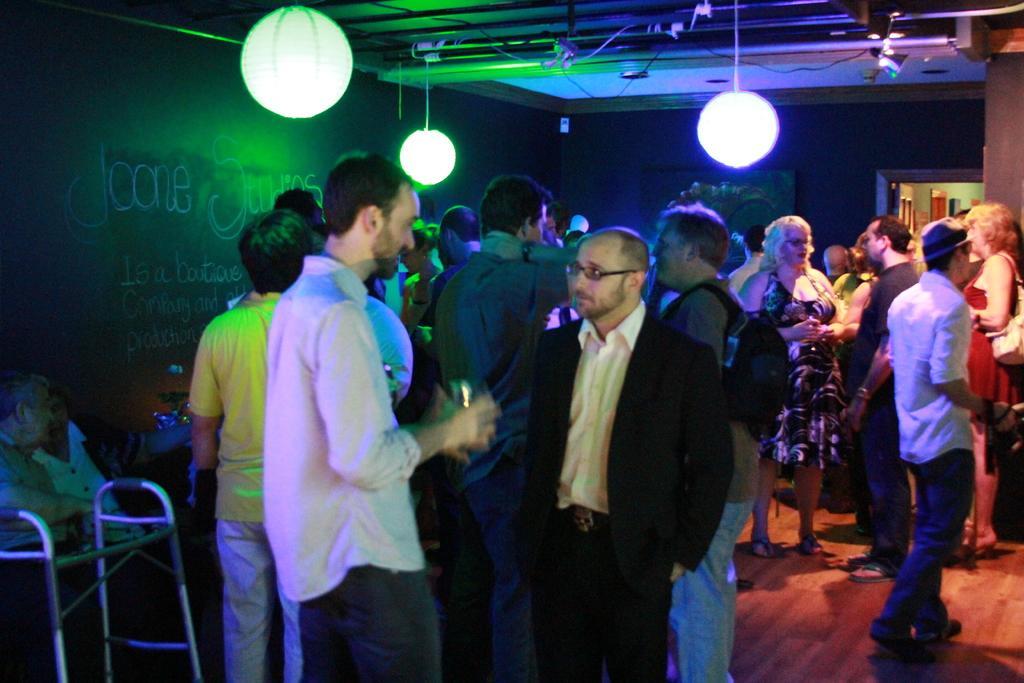Can you describe this image briefly? In this image we can see a group of people standing on the floor. One person is holding a glass in his hand. To the left side, we can see two persons sitting and a stand placed on the floor. In the background, we can see some lights and the door. 